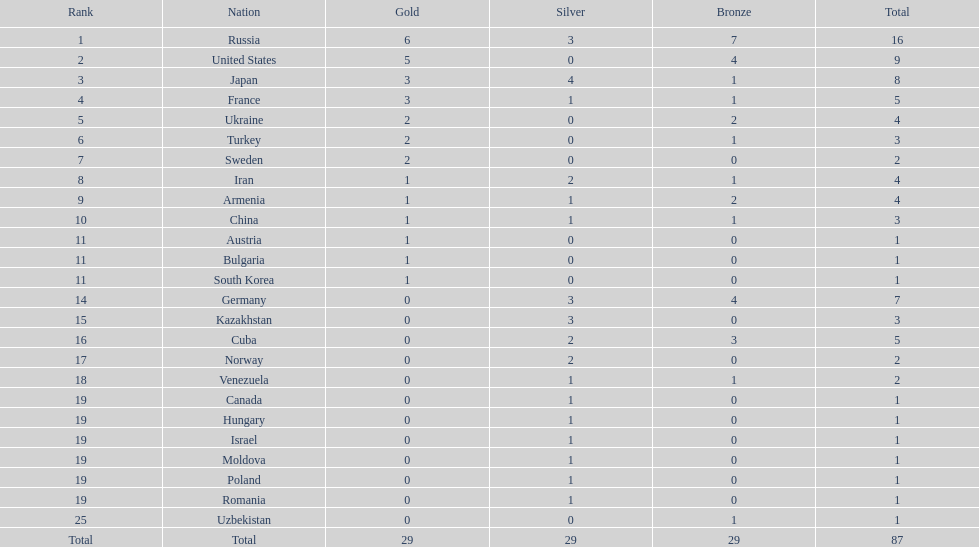How many countries have over 5 bronze medals in total? 1. 